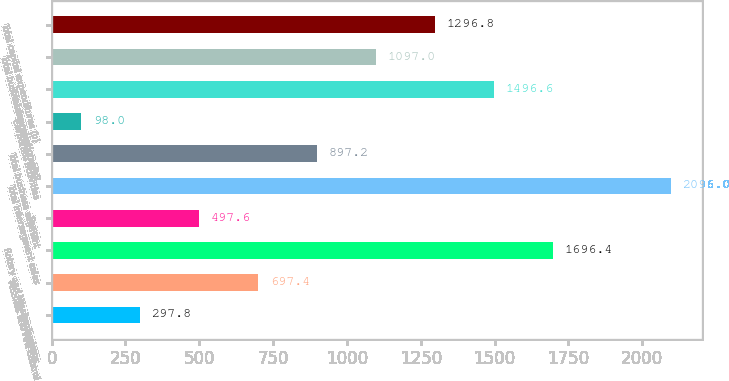Convert chart. <chart><loc_0><loc_0><loc_500><loc_500><bar_chart><fcel>Aeronautics<fcel>Missiles and Fire Control<fcel>Rotary and Mission Systems<fcel>Space<fcel>Total intersegment sales<fcel>Total business segment<fcel>Corporate activities<fcel>Total depreciation and<fcel>Total business segment capital<fcel>Total capital expenditures (b)<nl><fcel>297.8<fcel>697.4<fcel>1696.4<fcel>497.6<fcel>2096<fcel>897.2<fcel>98<fcel>1496.6<fcel>1097<fcel>1296.8<nl></chart> 